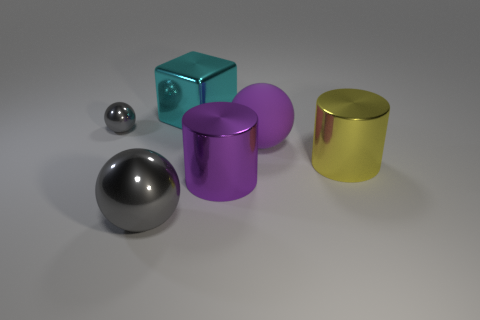Subtract all blue balls. Subtract all red cylinders. How many balls are left? 3 Add 2 small metallic things. How many objects exist? 8 Subtract all blocks. How many objects are left? 5 Add 4 tiny gray metal objects. How many tiny gray metal objects are left? 5 Add 5 big purple spheres. How many big purple spheres exist? 6 Subtract 0 purple blocks. How many objects are left? 6 Subtract all large rubber things. Subtract all cyan metal things. How many objects are left? 4 